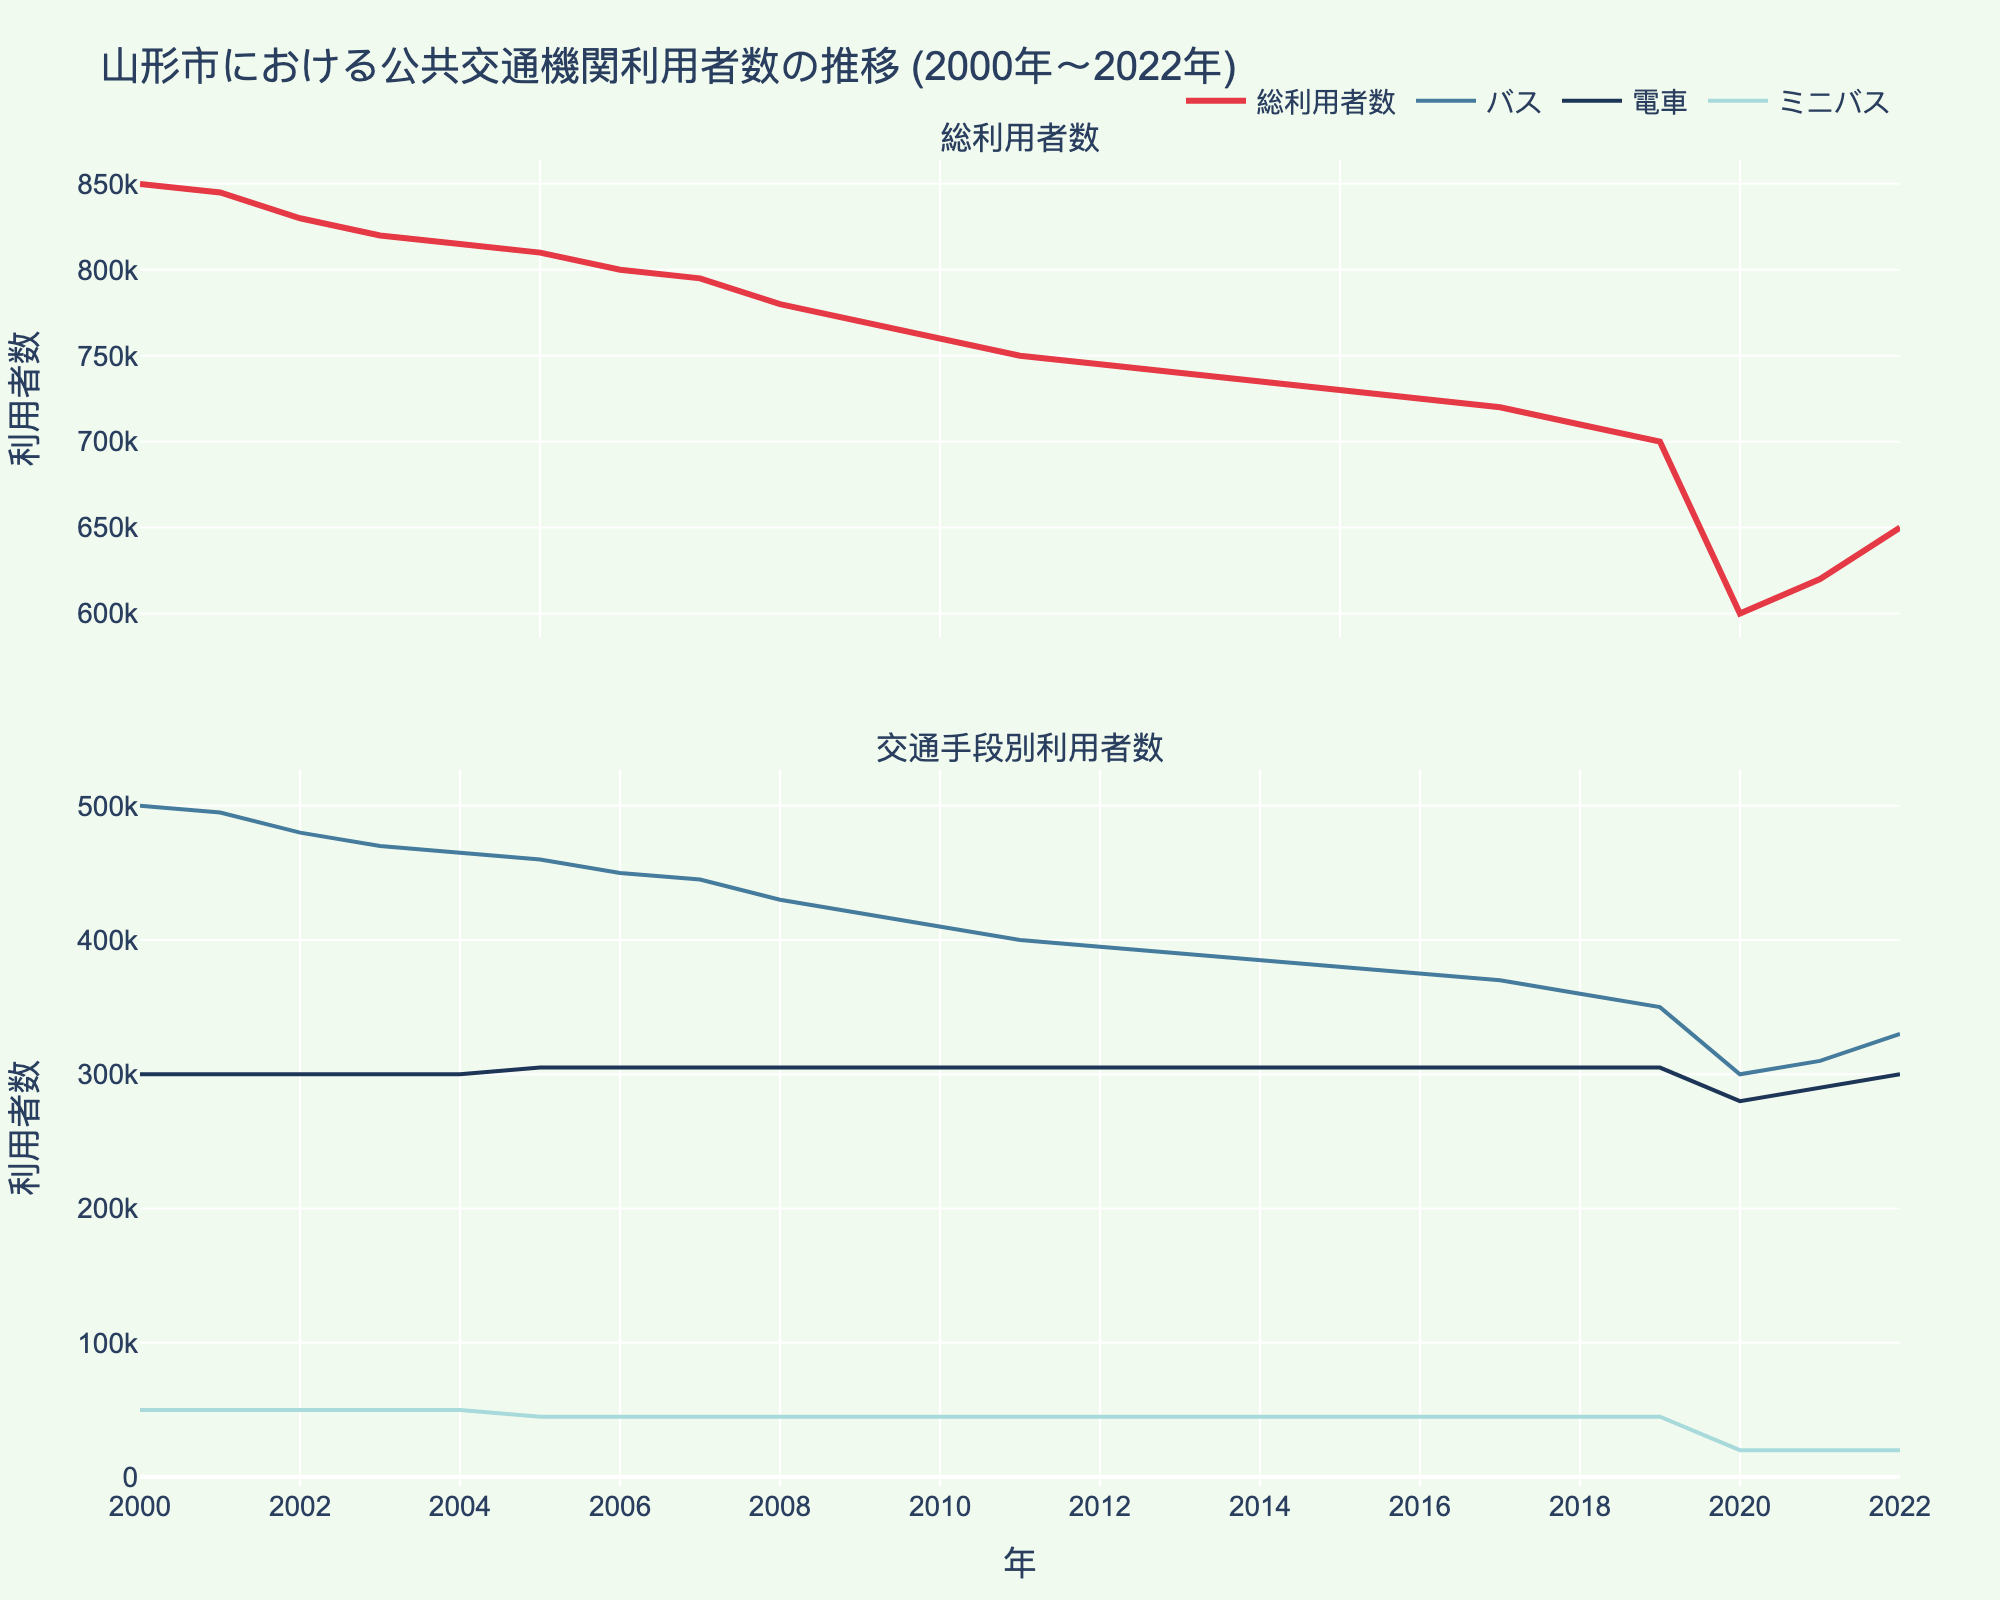What's the overall trend of total ridership from 2000 to 2022? Observing the total ridership line in the upper subplot, the ridership shows a declining trend from 2000 to 2019, followed by a significant decrease in 2020, and then a slight recovery from 2021 to 2022.
Answer: Declining with a slight recovery at the end In which year did the total ridership drop most dramatically? By examining the total ridership line in the upper subplot, the largest drop occurs between 2019 and 2020.
Answer: 2020 How did bus ridership change from 2000 to 2022? The bus ridership line in the lower subplot shows a declining trend from 2000 to 2019, a substantial drop in 2020, and then a slight increase from 2021 to 2022.
Answer: Declining with a drop in 2020 and slight increase at the end Which transportation mode had the least ridership in 2022? Checking the lower subplot, the minibus ridership in 2022 is lower compared to bus and train ridership.
Answer: Minibus What is the color used to represent train ridership in the plot? The train ridership line in the lower subplot is represented by a dark blue color.
Answer: Dark blue How much did train ridership change between 2019 and 2020? In the lower subplot, train ridership decreases from 305,000 in 2019 to 280,000 in 2020. The change is 305,000 - 280,000.
Answer: 25,000 Compare the bus and minibus ridership in 2005. Which one was higher and by how much? From the lower subplot, bus ridership in 2005 is 460,000 and minibus ridership is 45,000. The difference is 460,000 - 45,000.
Answer: Bus by 415,000 Did any transportation mode show an increase in ridership from 2000 to 2022? From the lower subplot, observing the lines, none of the transportation modes show an increase; they all decline over the period.
Answer: No What was the total ridership in 2015? Observing the upper subplot, the total ridership value for 2015 is marked at 730,000.
Answer: 730,000 How did the total ridership in 2022 compare to that in 2000? Using the upper subplot, total ridership in 2000 is 850,000 and in 2022 it is 650,000. The ridership in 2022 is significantly lower.
Answer: Lower in 2022 